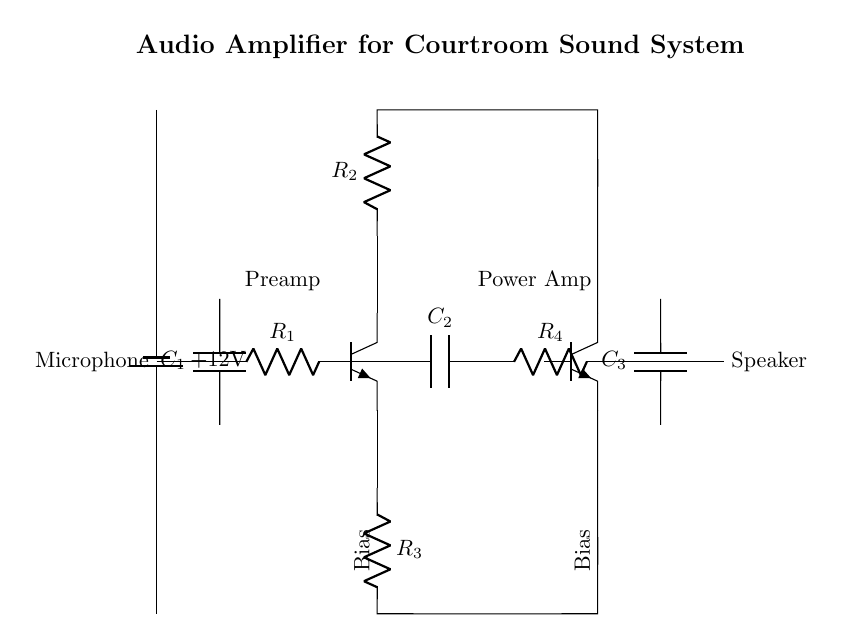What is the main purpose of the circuit? The circuit is designed to amplify audio signals for better sound projection, particularly in a courtroom setting.
Answer: Amplification What components are used for coupling the audio signal? The coupling capacitors used in the circuit for this purpose are identified as C1 and C2, which allow AC signals while blocking DC components.
Answer: C1, C2 How many transistors are used in this amplifier circuit? There are two transistors present, labeled as Q1 and Q2, which are employed to amplify the electrical signal.
Answer: Two What is the role of the resistors in the preamp stage? The resistors, R1, R2, and R3, are crucial in setting the gain, controlling the current flow, and stabilizing the bias point for the transistors during amplification.
Answer: Gain and bias stabilization What is the power supply voltage for the circuit? The circuit is powered by a battery that supplies a voltage of 12 volts across its terminals, which is used to operate the transistors and other components.
Answer: Twelve volts What type of amplifier stage follows the preamp stage? The circuit diagram shows that after the preamp stage, there is a power amplifier stage designed to further boost the audio signal's power before sending it to the speaker.
Answer: Power amplifier 